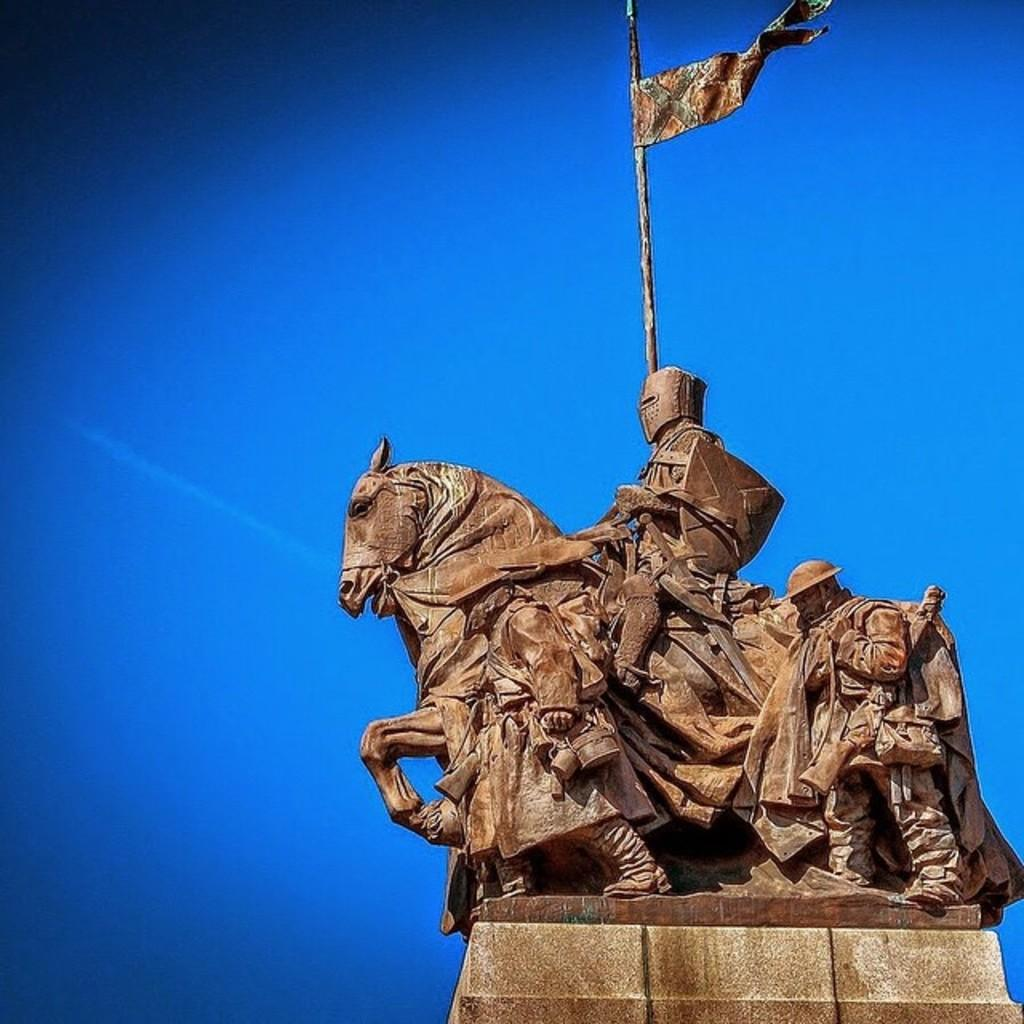What is the main subject in the image? There is a statue in the image. What can be seen in the background of the image? The sky is visible in the background of the image. What type of whip can be seen in the image? There is no whip present in the image; it only features a statue and the sky in the background. 